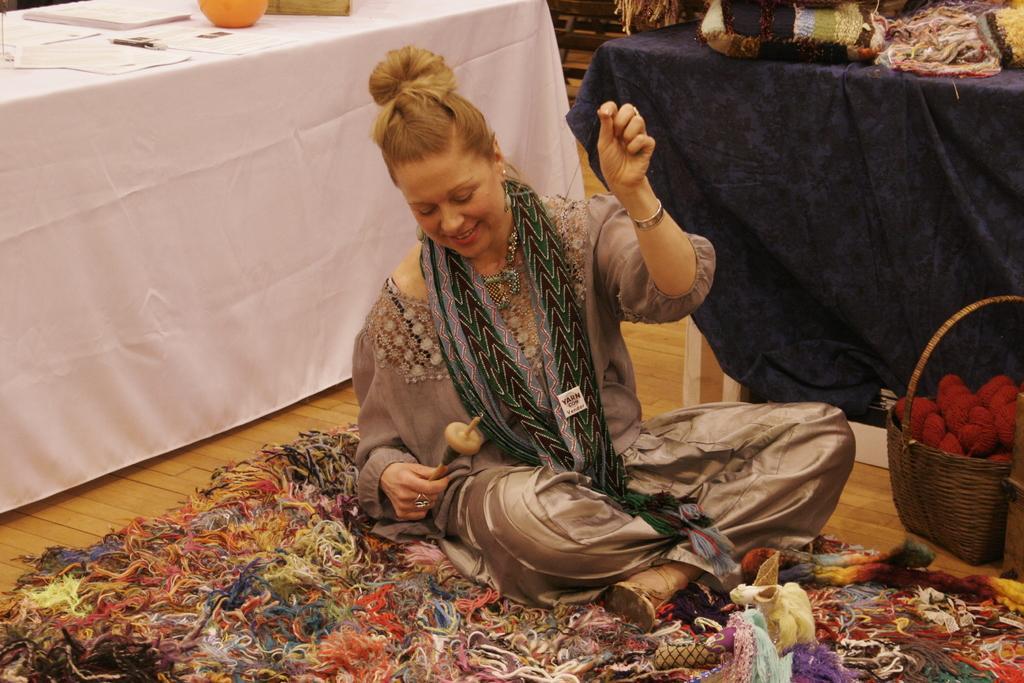Can you describe this image briefly? In the foreground of this image, a woman sitting on the carpet and holding a rod wrapping thread like an object in her hand. Beside her, there is a basket and few objects in it. In the background, there are two tables on which few objects are placed. 